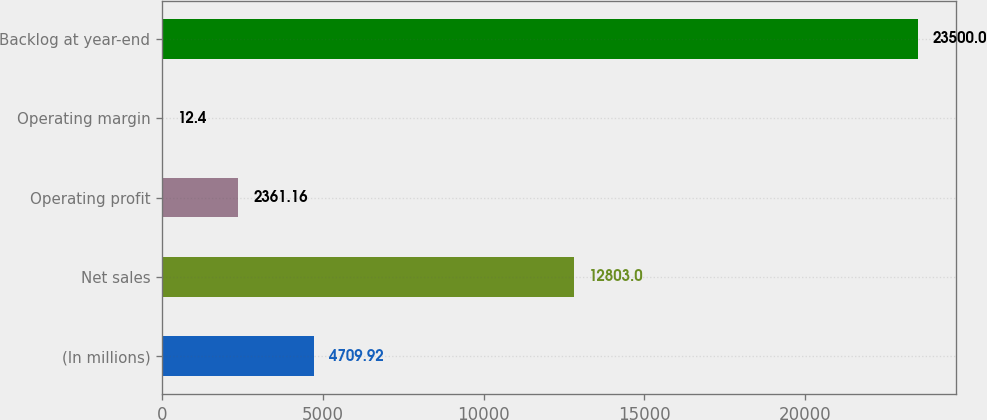<chart> <loc_0><loc_0><loc_500><loc_500><bar_chart><fcel>(In millions)<fcel>Net sales<fcel>Operating profit<fcel>Operating margin<fcel>Backlog at year-end<nl><fcel>4709.92<fcel>12803<fcel>2361.16<fcel>12.4<fcel>23500<nl></chart> 